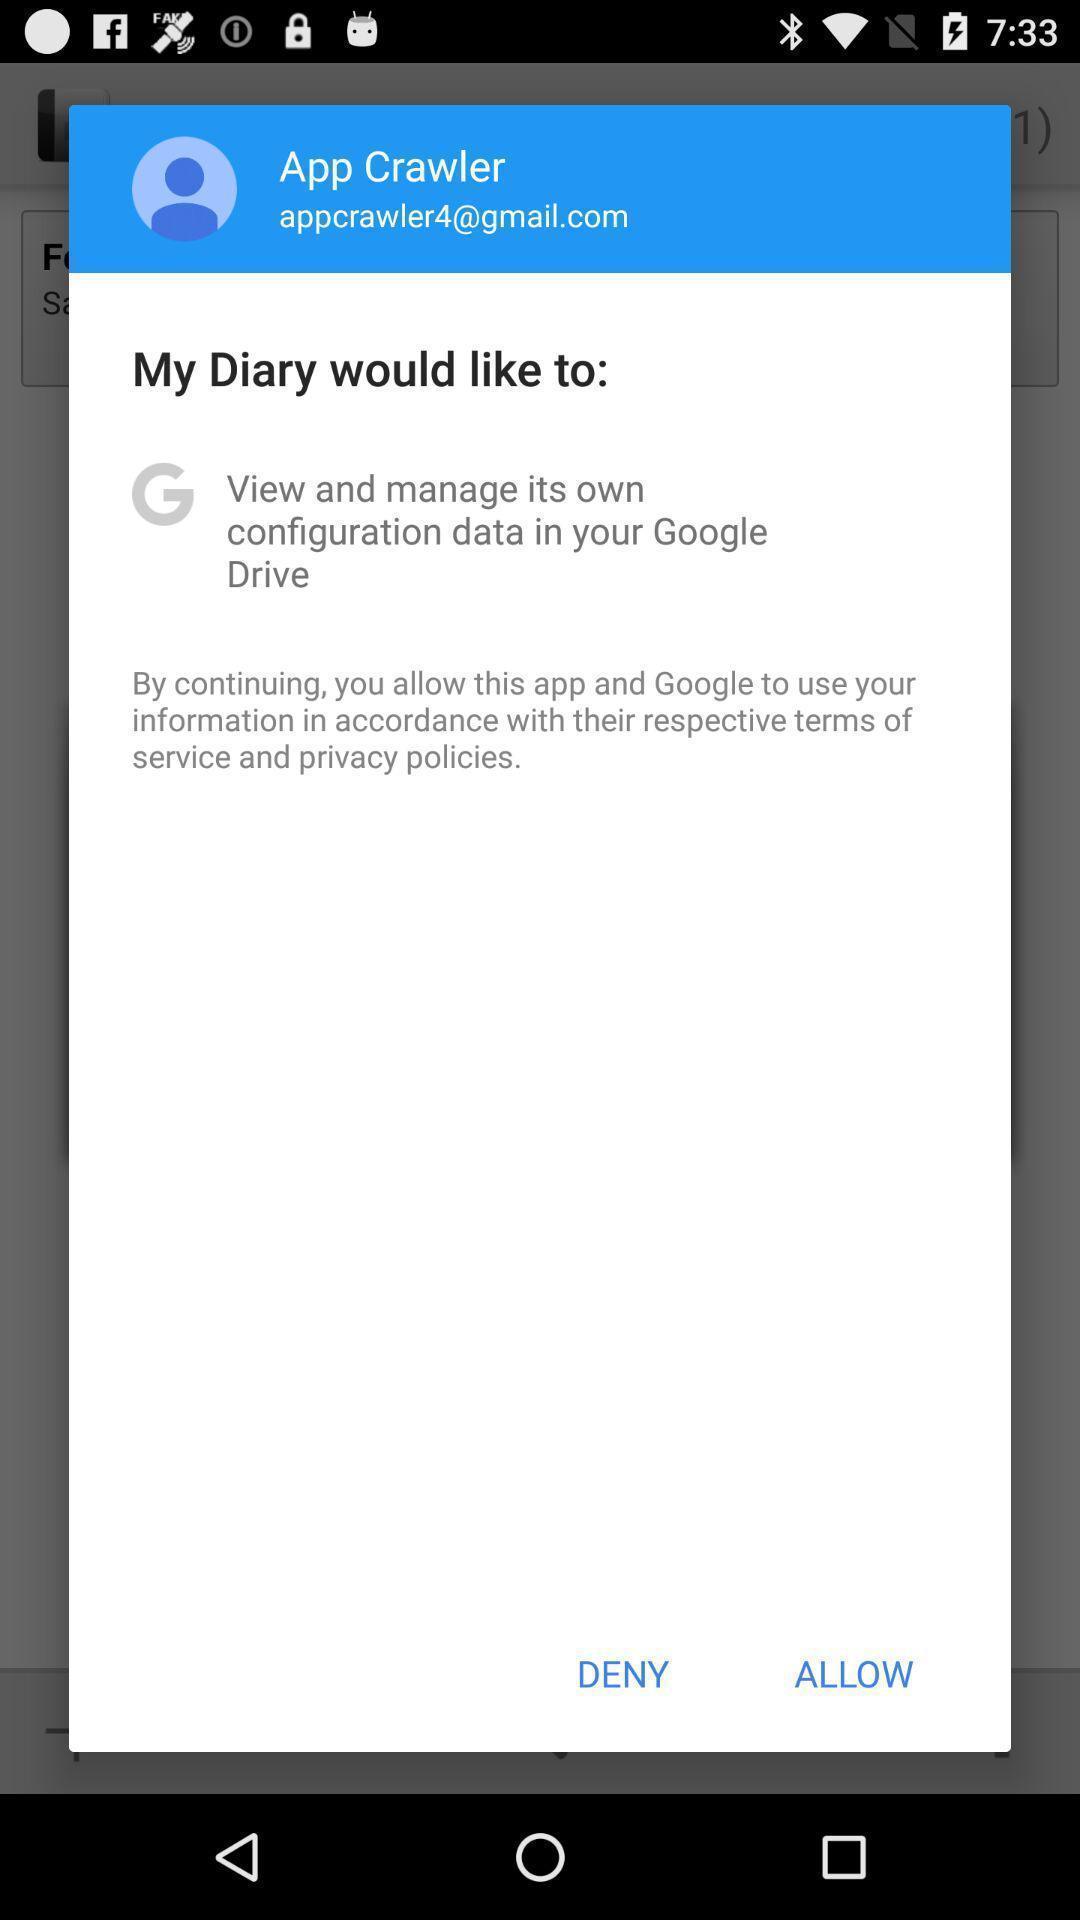Describe the key features of this screenshot. Pop-up for allow or deny to accept privacy policies. 